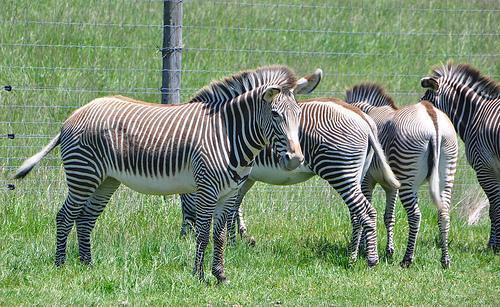How many zebras are in the photo?
Give a very brief answer. 4. 